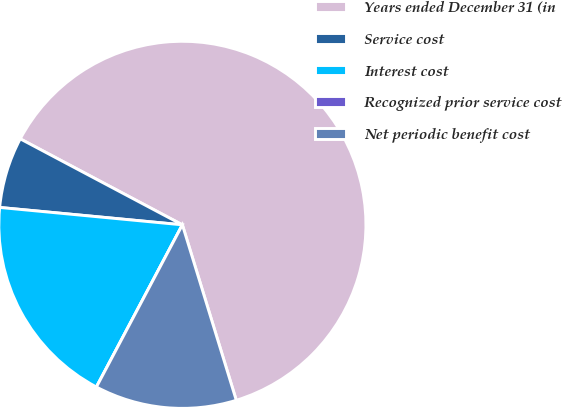Convert chart to OTSL. <chart><loc_0><loc_0><loc_500><loc_500><pie_chart><fcel>Years ended December 31 (in<fcel>Service cost<fcel>Interest cost<fcel>Recognized prior service cost<fcel>Net periodic benefit cost<nl><fcel>62.49%<fcel>6.25%<fcel>18.75%<fcel>0.0%<fcel>12.5%<nl></chart> 